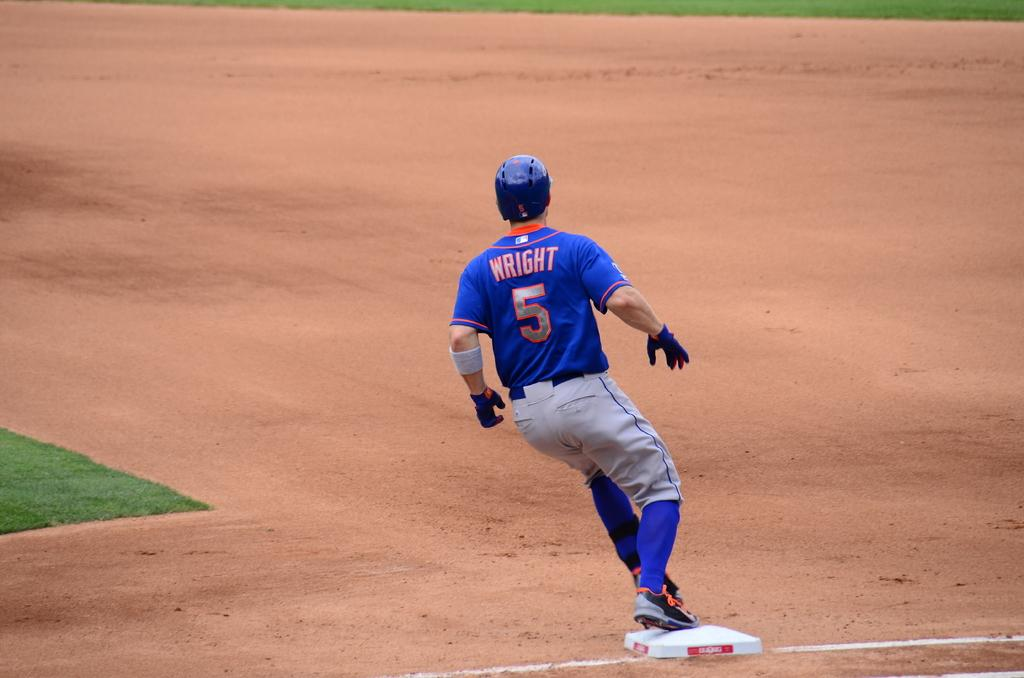<image>
Give a short and clear explanation of the subsequent image. A baseball player called Wright and who is number 5 and wears a blue top runs the bases. 